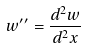<formula> <loc_0><loc_0><loc_500><loc_500>w ^ { \prime \prime } = \frac { d ^ { 2 } w } { d ^ { 2 } x }</formula> 